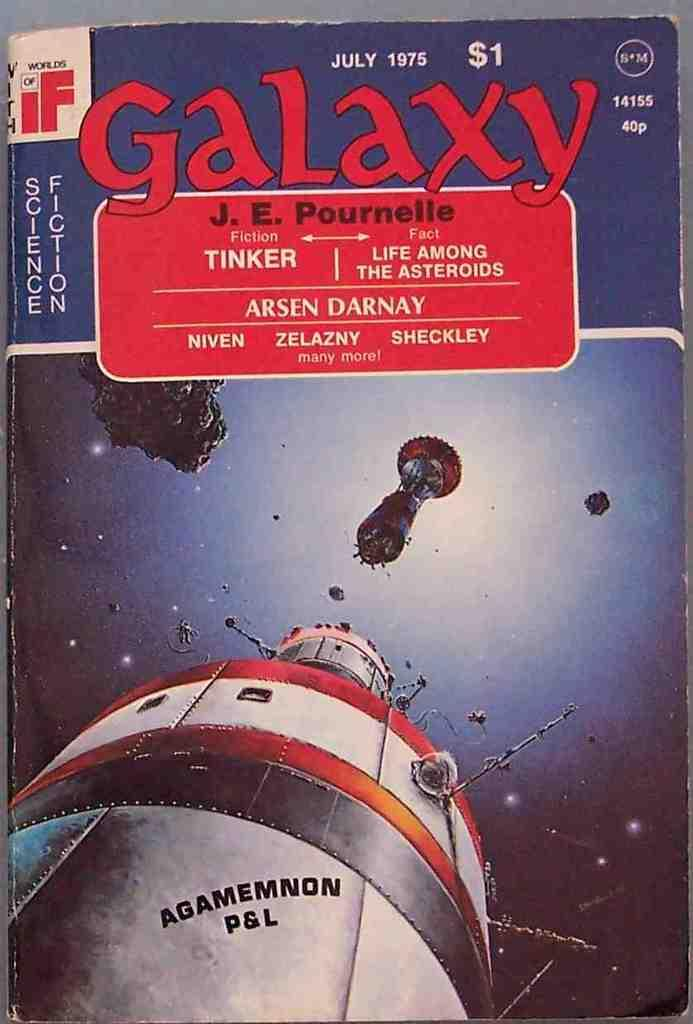<image>
Present a compact description of the photo's key features. A Galaxy $1 July 1975 Science Fiction postal ticket or entrance ticket showing Agamemnon P&L 